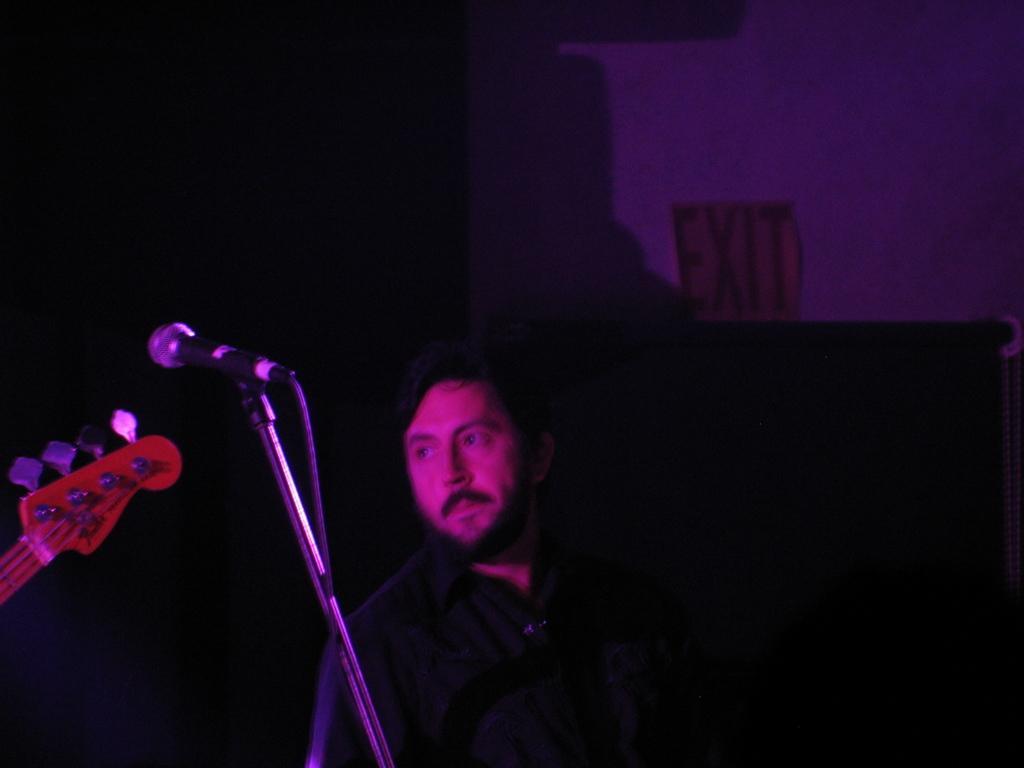Could you give a brief overview of what you see in this image? The photo is clicked inside the dark room. In the middle of this picture, we see a man in black shirt is standing. Beside him, we see a microphone and a musical instrument. 